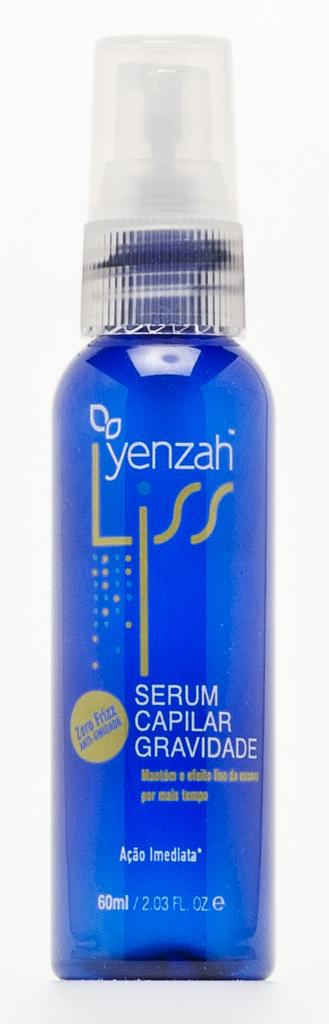<image>
Summarize the visual content of the image. A blue bottle contains a serum from Yenzah. 